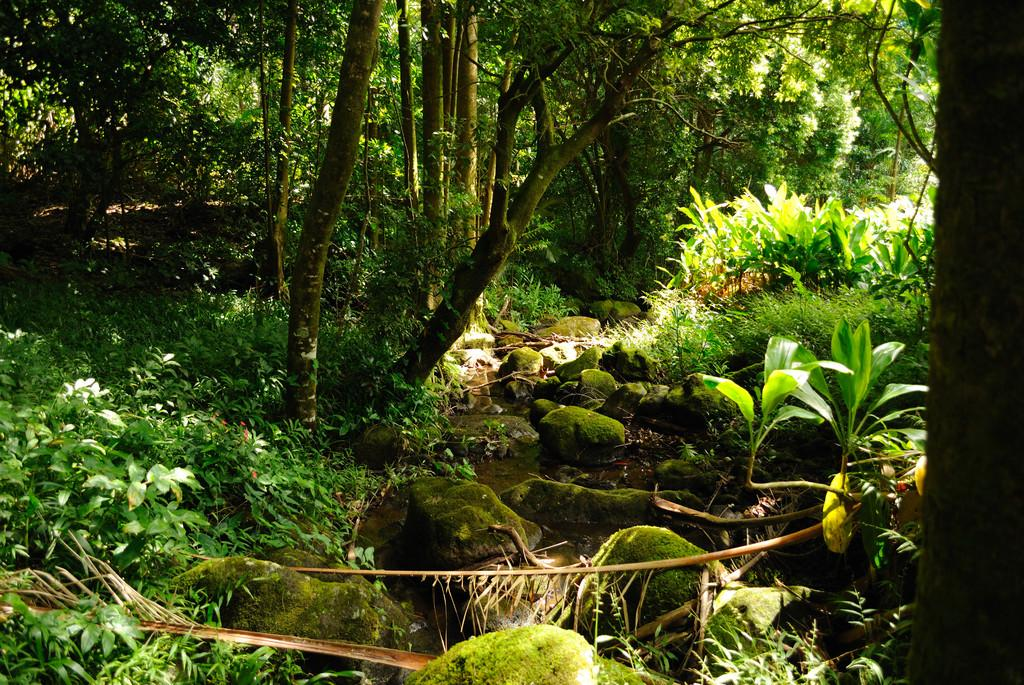What is present at the bottom of the picture? There are rocks and trees at the bottom of the picture. What else can be seen at the bottom of the picture? There are trees at the bottom of the picture. What is visible in the background of the picture? There are trees in the background of the picture. What type of environment might the image depict? The image might have been taken in a forest, given the presence of trees and rocks. What type of pizzas can be seen hanging from the trees in the image? There are no pizzas present in the image; it features rocks and trees. What instrument is being played by the trees in the background of the image? There is no instrument being played by the trees in the image; they are simply trees in the background. 